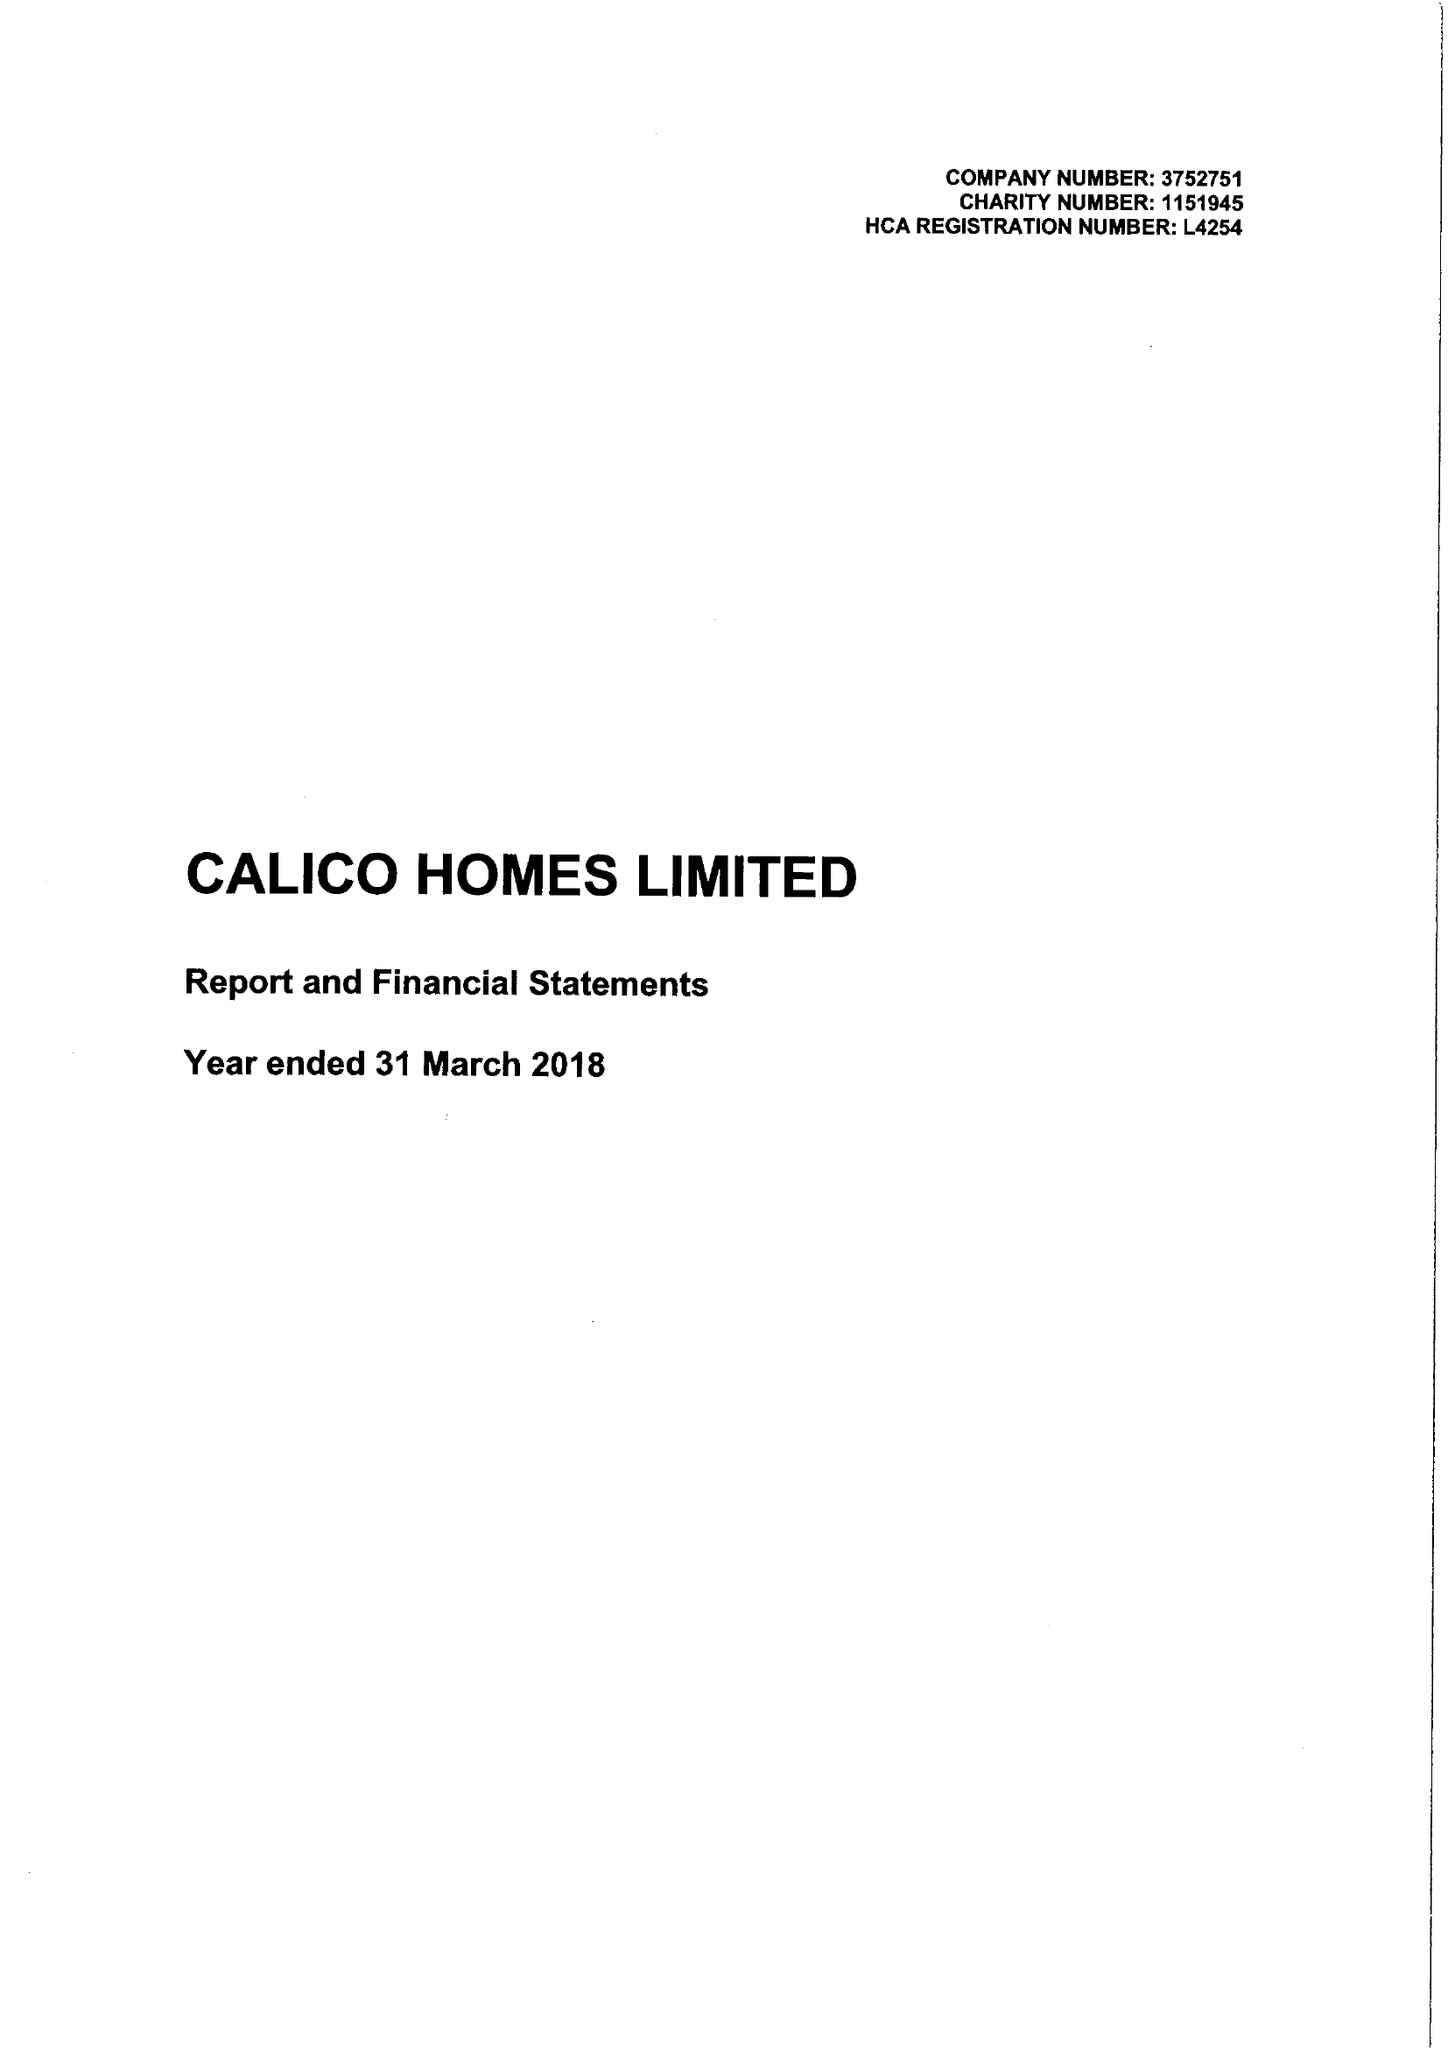What is the value for the address__street_line?
Answer the question using a single word or phrase. CROFT STREET 